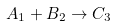<formula> <loc_0><loc_0><loc_500><loc_500>A _ { 1 } + B _ { 2 } \rightarrow C _ { 3 }</formula> 